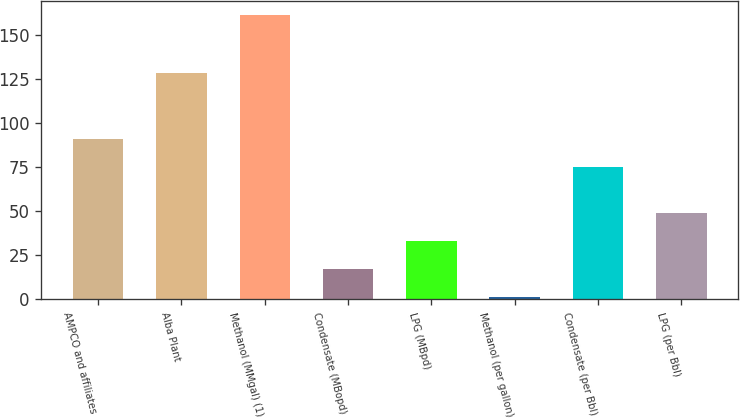Convert chart. <chart><loc_0><loc_0><loc_500><loc_500><bar_chart><fcel>AMPCO and affiliates<fcel>Alba Plant<fcel>Methanol (MMgal) (1)<fcel>Condensate (MBopd)<fcel>LPG (MBpd)<fcel>Methanol (per gallon)<fcel>Condensate (per Bbl)<fcel>LPG (per Bbl)<nl><fcel>90.86<fcel>128<fcel>161<fcel>17.08<fcel>33.07<fcel>1.09<fcel>74.87<fcel>49.06<nl></chart> 